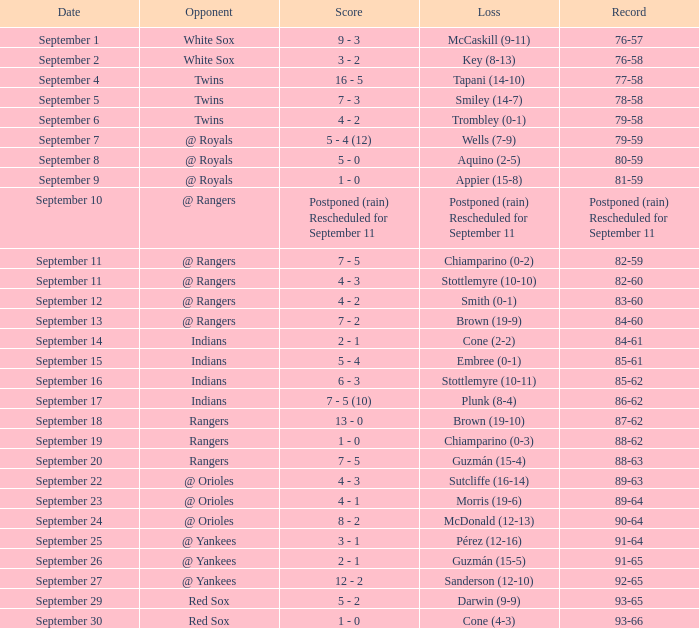What's the deficit for september 16? Stottlemyre (10-11). 